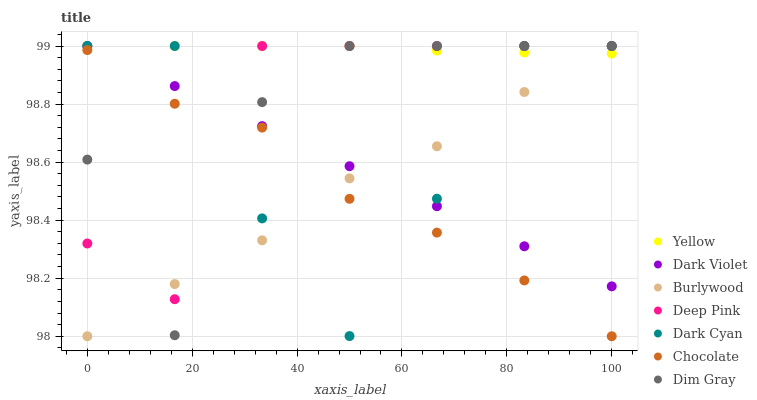Does Chocolate have the minimum area under the curve?
Answer yes or no. Yes. Does Yellow have the maximum area under the curve?
Answer yes or no. Yes. Does Burlywood have the minimum area under the curve?
Answer yes or no. No. Does Burlywood have the maximum area under the curve?
Answer yes or no. No. Is Dark Violet the smoothest?
Answer yes or no. Yes. Is Dark Cyan the roughest?
Answer yes or no. Yes. Is Burlywood the smoothest?
Answer yes or no. No. Is Burlywood the roughest?
Answer yes or no. No. Does Burlywood have the lowest value?
Answer yes or no. Yes. Does Dark Violet have the lowest value?
Answer yes or no. No. Does Dark Cyan have the highest value?
Answer yes or no. Yes. Does Chocolate have the highest value?
Answer yes or no. No. Is Chocolate less than Yellow?
Answer yes or no. Yes. Is Dark Violet greater than Chocolate?
Answer yes or no. Yes. Does Dark Violet intersect Dark Cyan?
Answer yes or no. Yes. Is Dark Violet less than Dark Cyan?
Answer yes or no. No. Is Dark Violet greater than Dark Cyan?
Answer yes or no. No. Does Chocolate intersect Yellow?
Answer yes or no. No. 